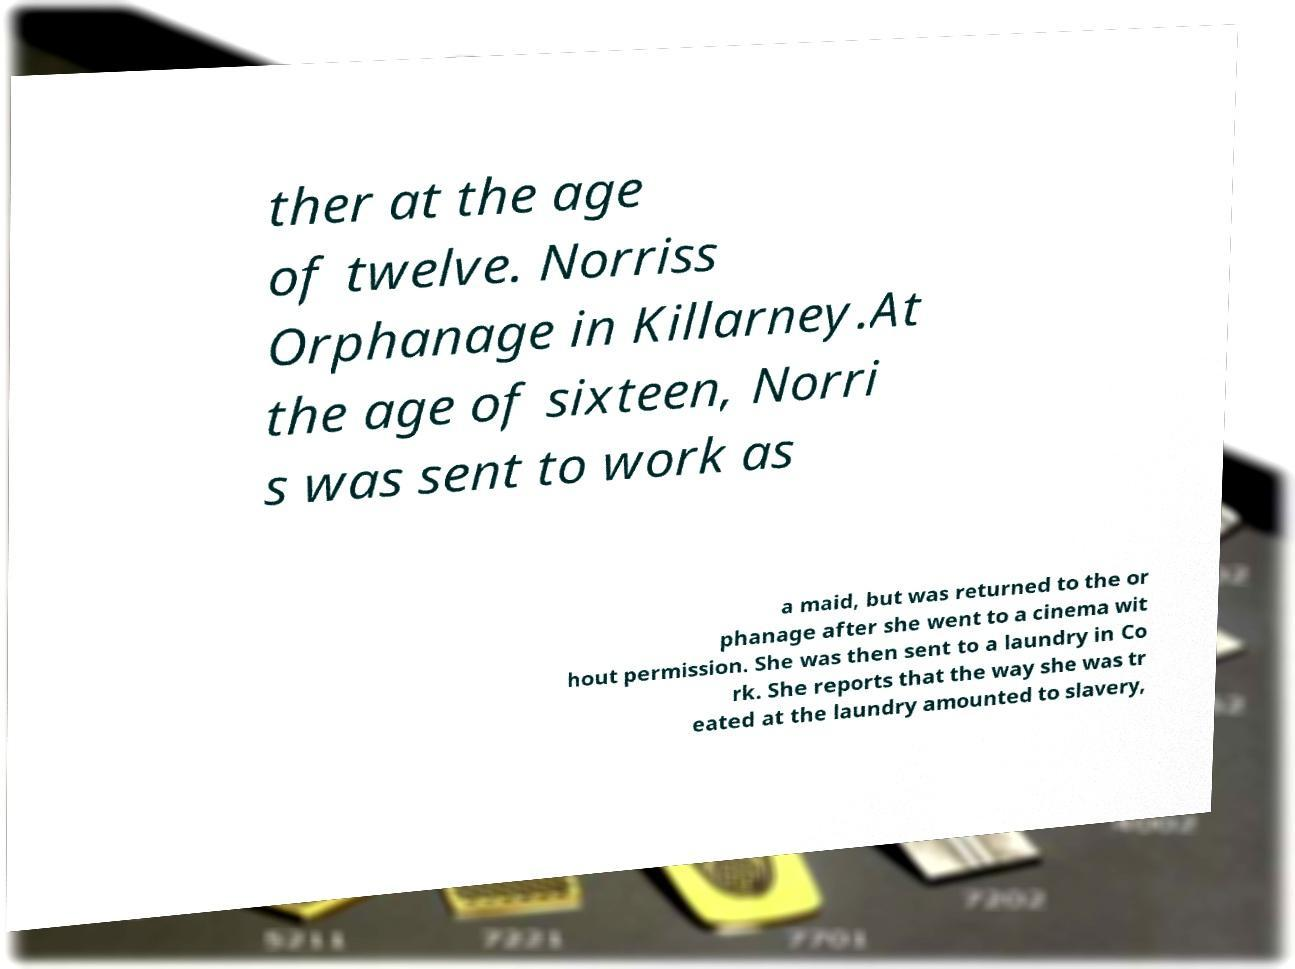Please read and relay the text visible in this image. What does it say? ther at the age of twelve. Norriss Orphanage in Killarney.At the age of sixteen, Norri s was sent to work as a maid, but was returned to the or phanage after she went to a cinema wit hout permission. She was then sent to a laundry in Co rk. She reports that the way she was tr eated at the laundry amounted to slavery, 